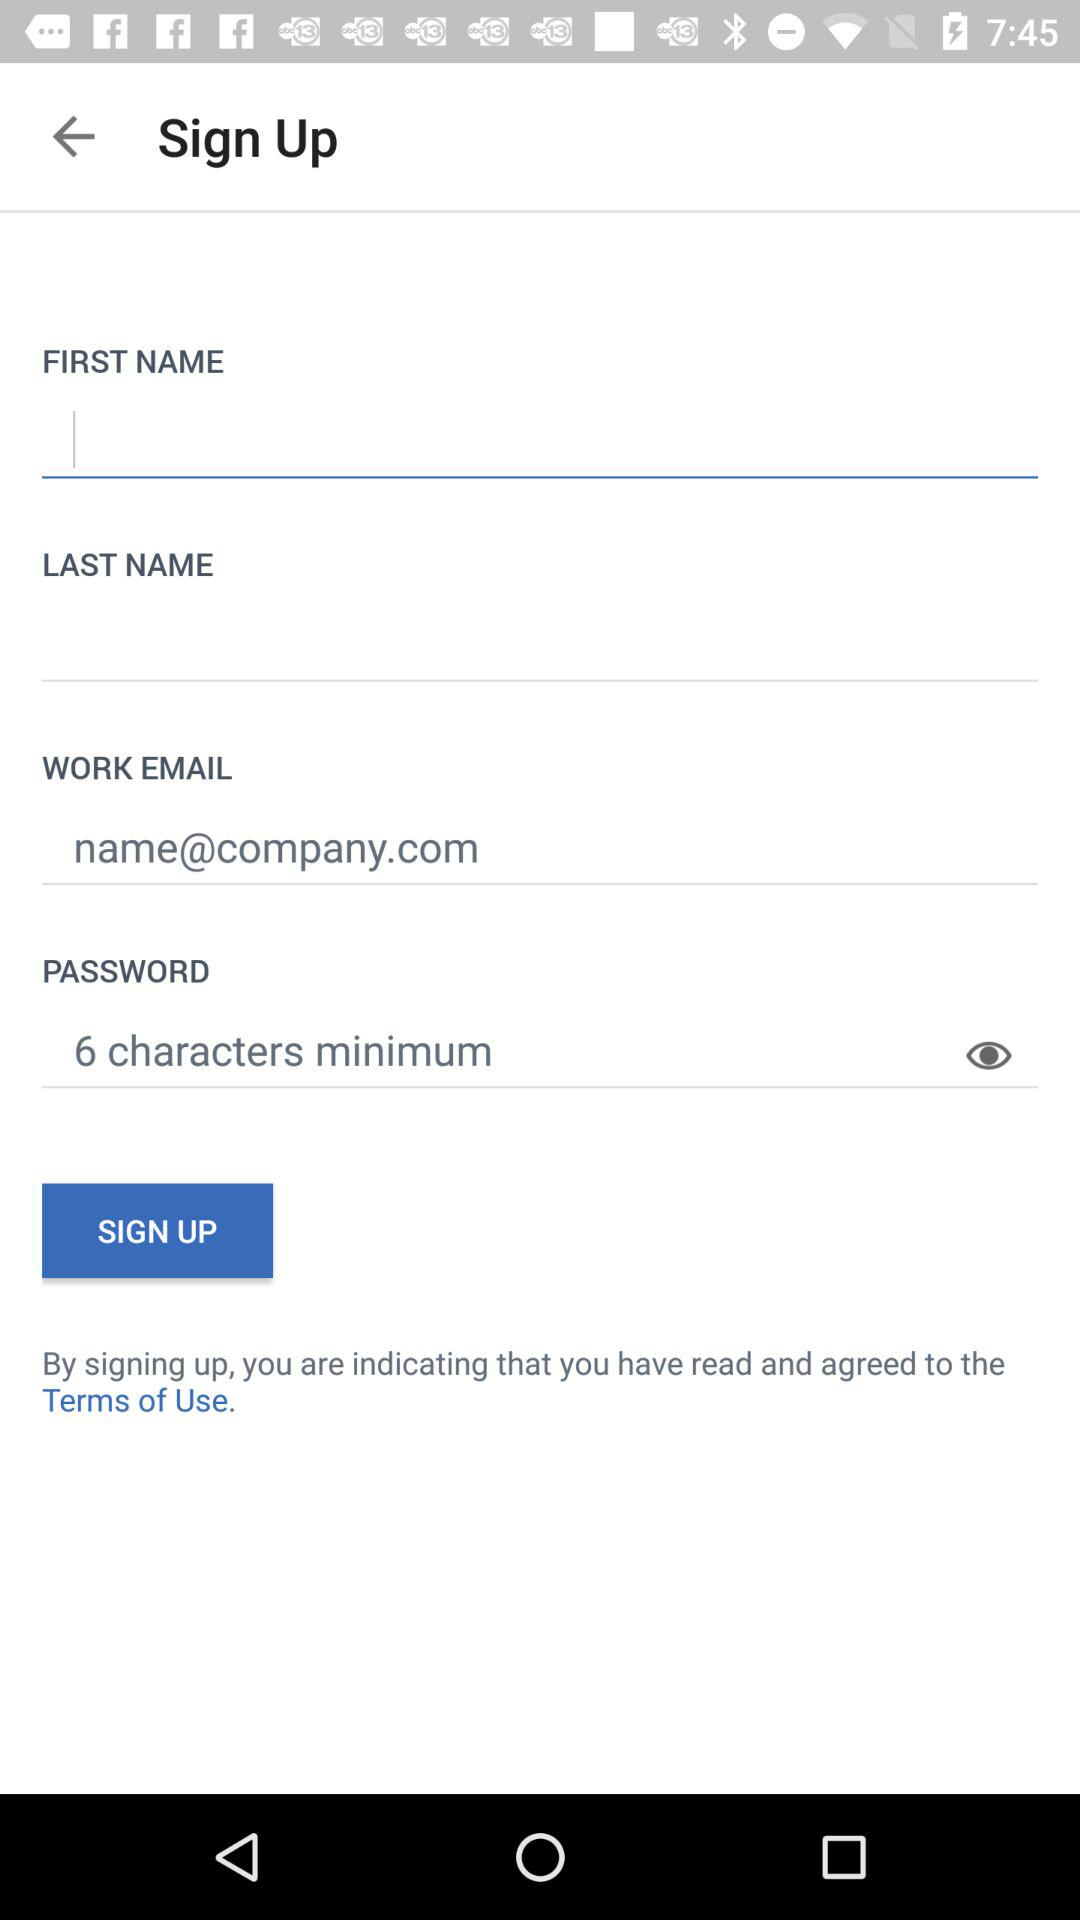What is the work email address? The work email address is name@company.com. 